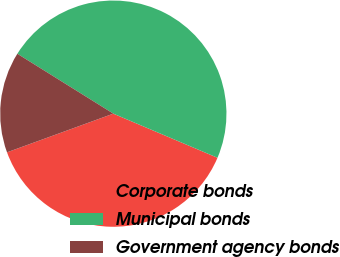<chart> <loc_0><loc_0><loc_500><loc_500><pie_chart><fcel>Corporate bonds<fcel>Municipal bonds<fcel>Government agency bonds<nl><fcel>38.07%<fcel>47.5%<fcel>14.43%<nl></chart> 